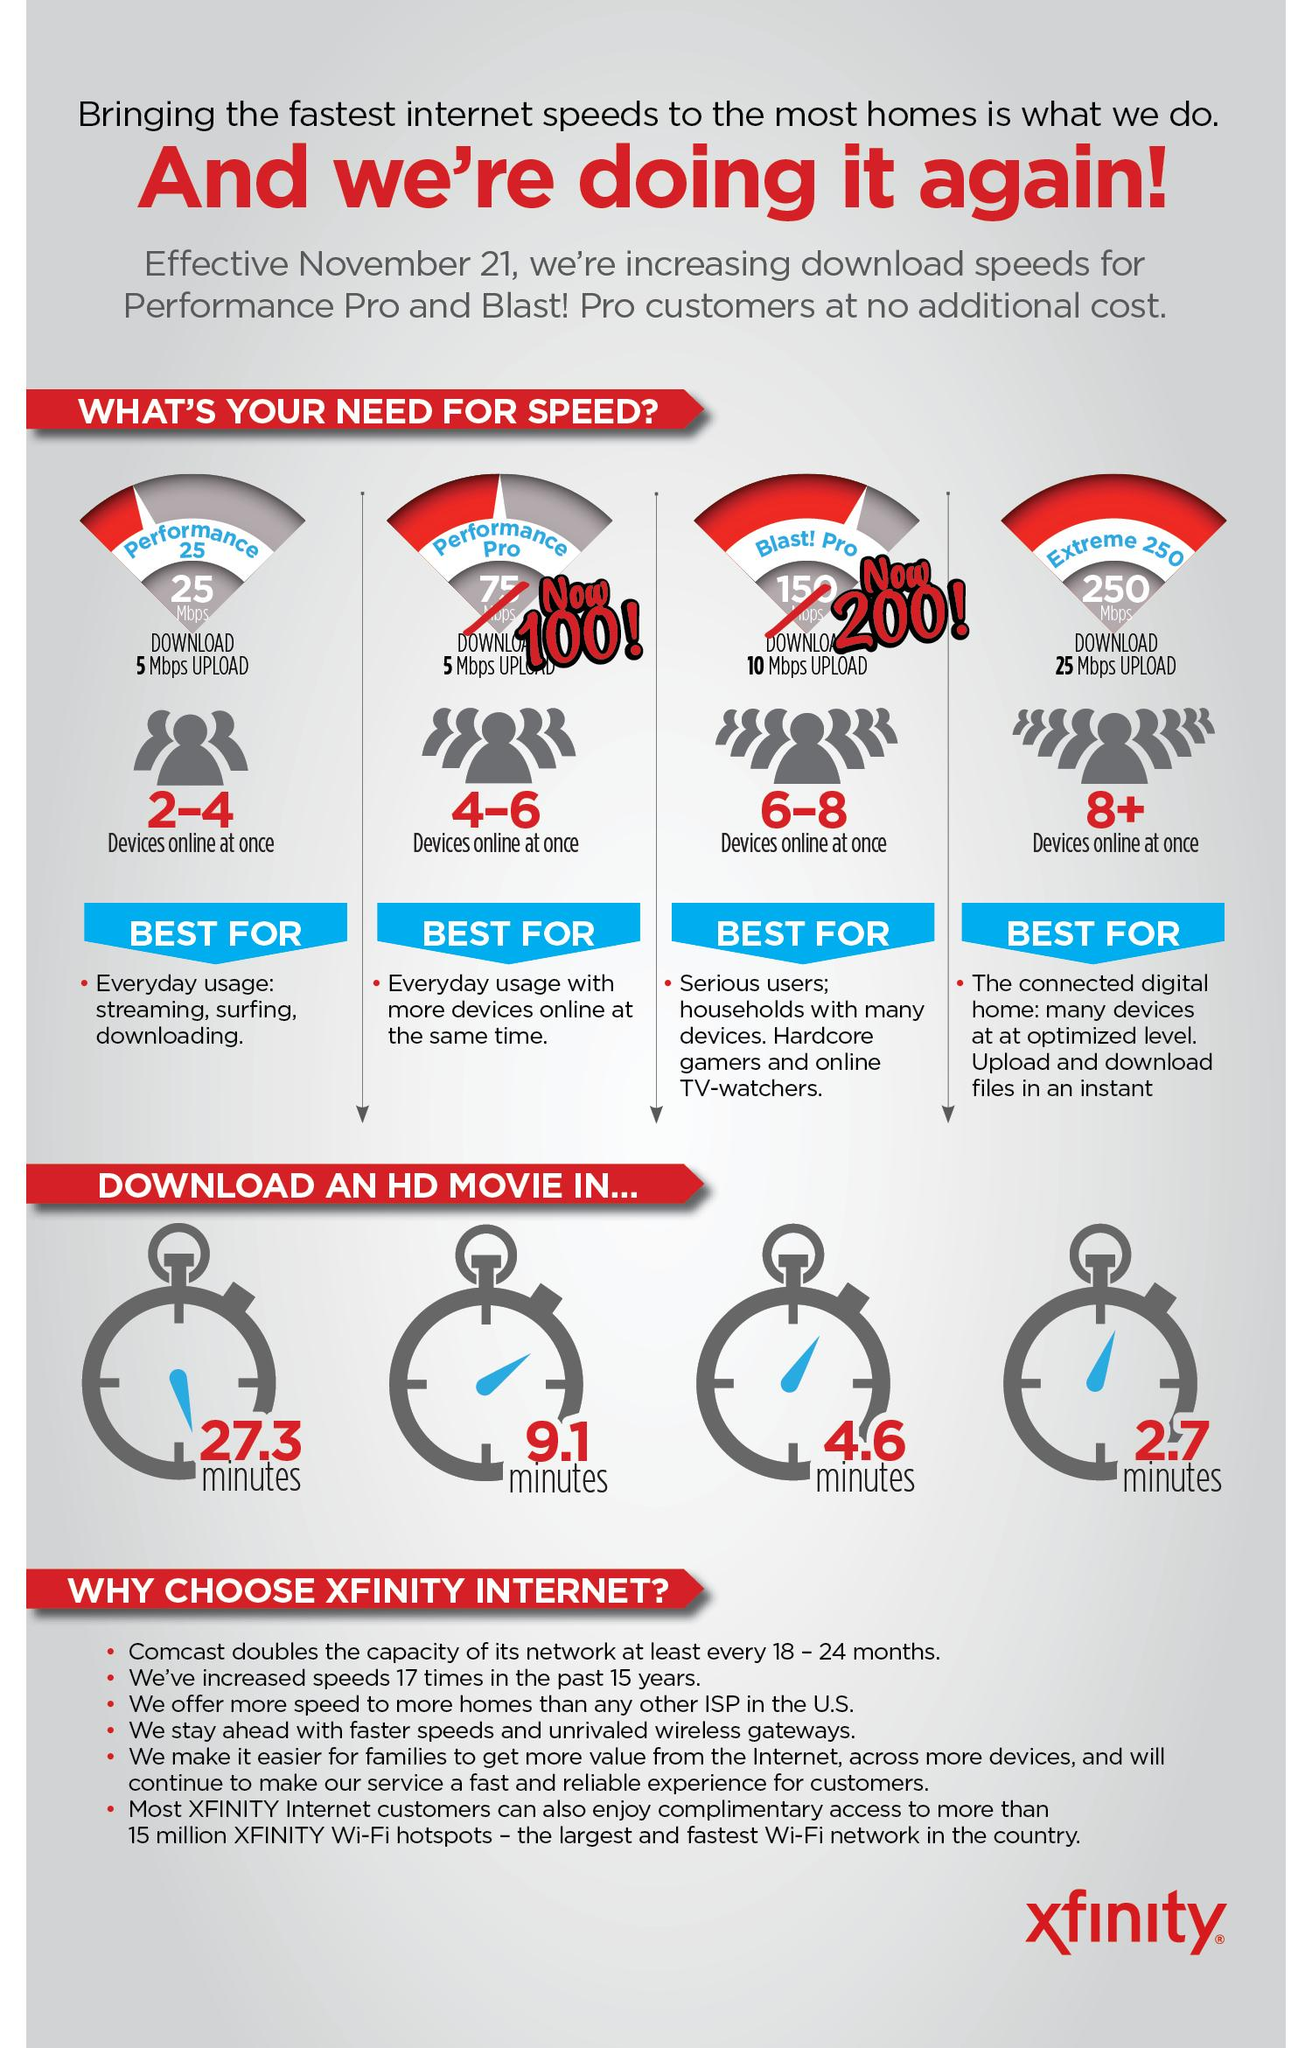Identify some key points in this picture. The internet package with a download speed of 250 Mbps is either Extreme 250, BlastPro, or Performance Pro. Extreme 250 is the correct answer. Our Performance Pro internet package takes the longest time to download a high-definition movie compared to other internet packages. Blast!Pro takes approximately 4.6 minutes to download a high-definition movie. The Extreme 250 internet package is the one that takes the least amount of time to download a high definition movie. Of the internet packages available, those with a 5 Mbps upload speed include Performance 25 and Performance Pro. 